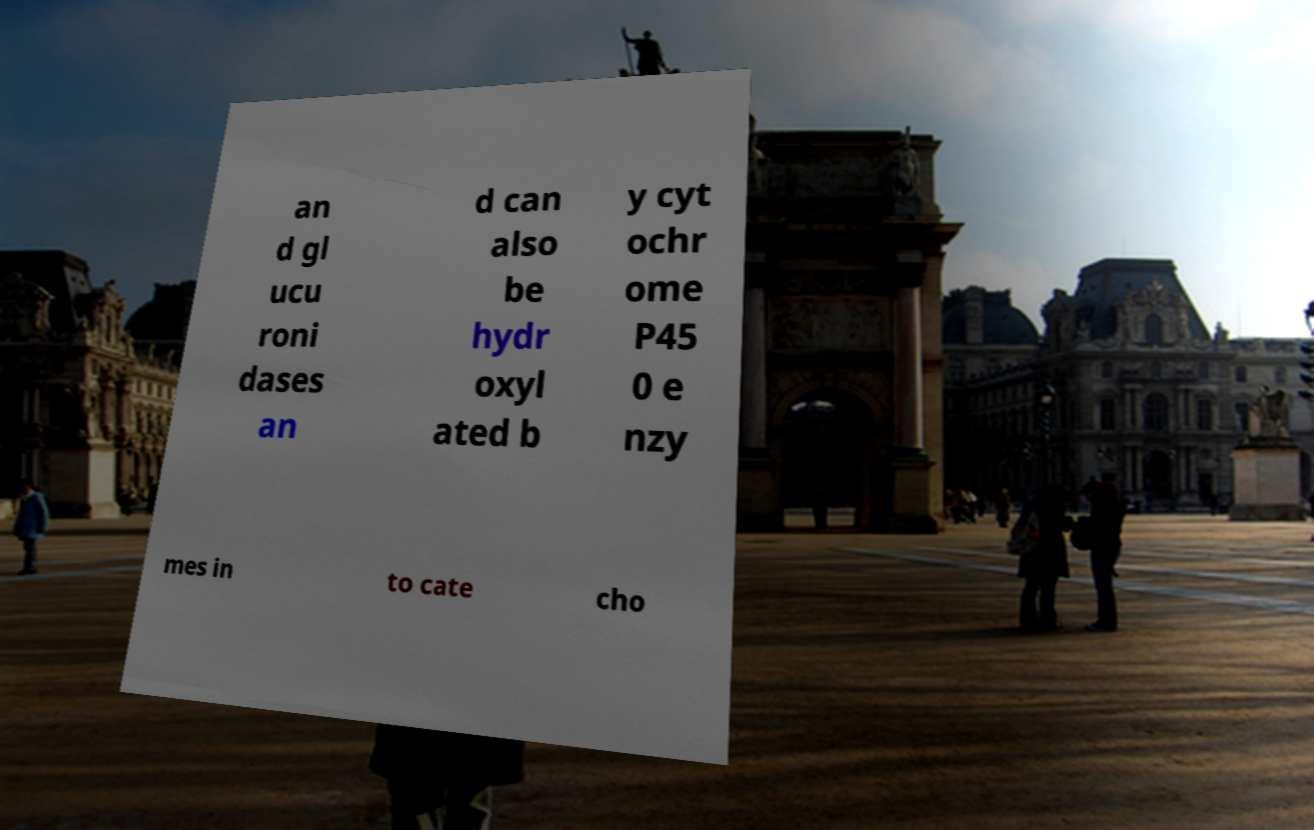Can you accurately transcribe the text from the provided image for me? an d gl ucu roni dases an d can also be hydr oxyl ated b y cyt ochr ome P45 0 e nzy mes in to cate cho 